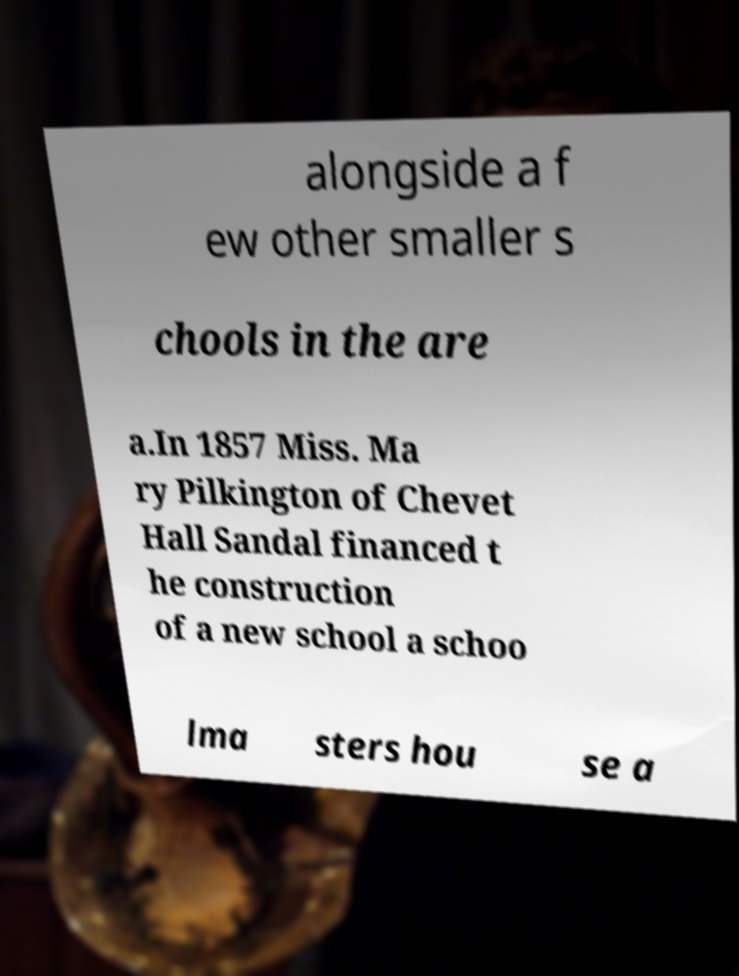Please identify and transcribe the text found in this image. alongside a f ew other smaller s chools in the are a.In 1857 Miss. Ma ry Pilkington of Chevet Hall Sandal financed t he construction of a new school a schoo lma sters hou se a 